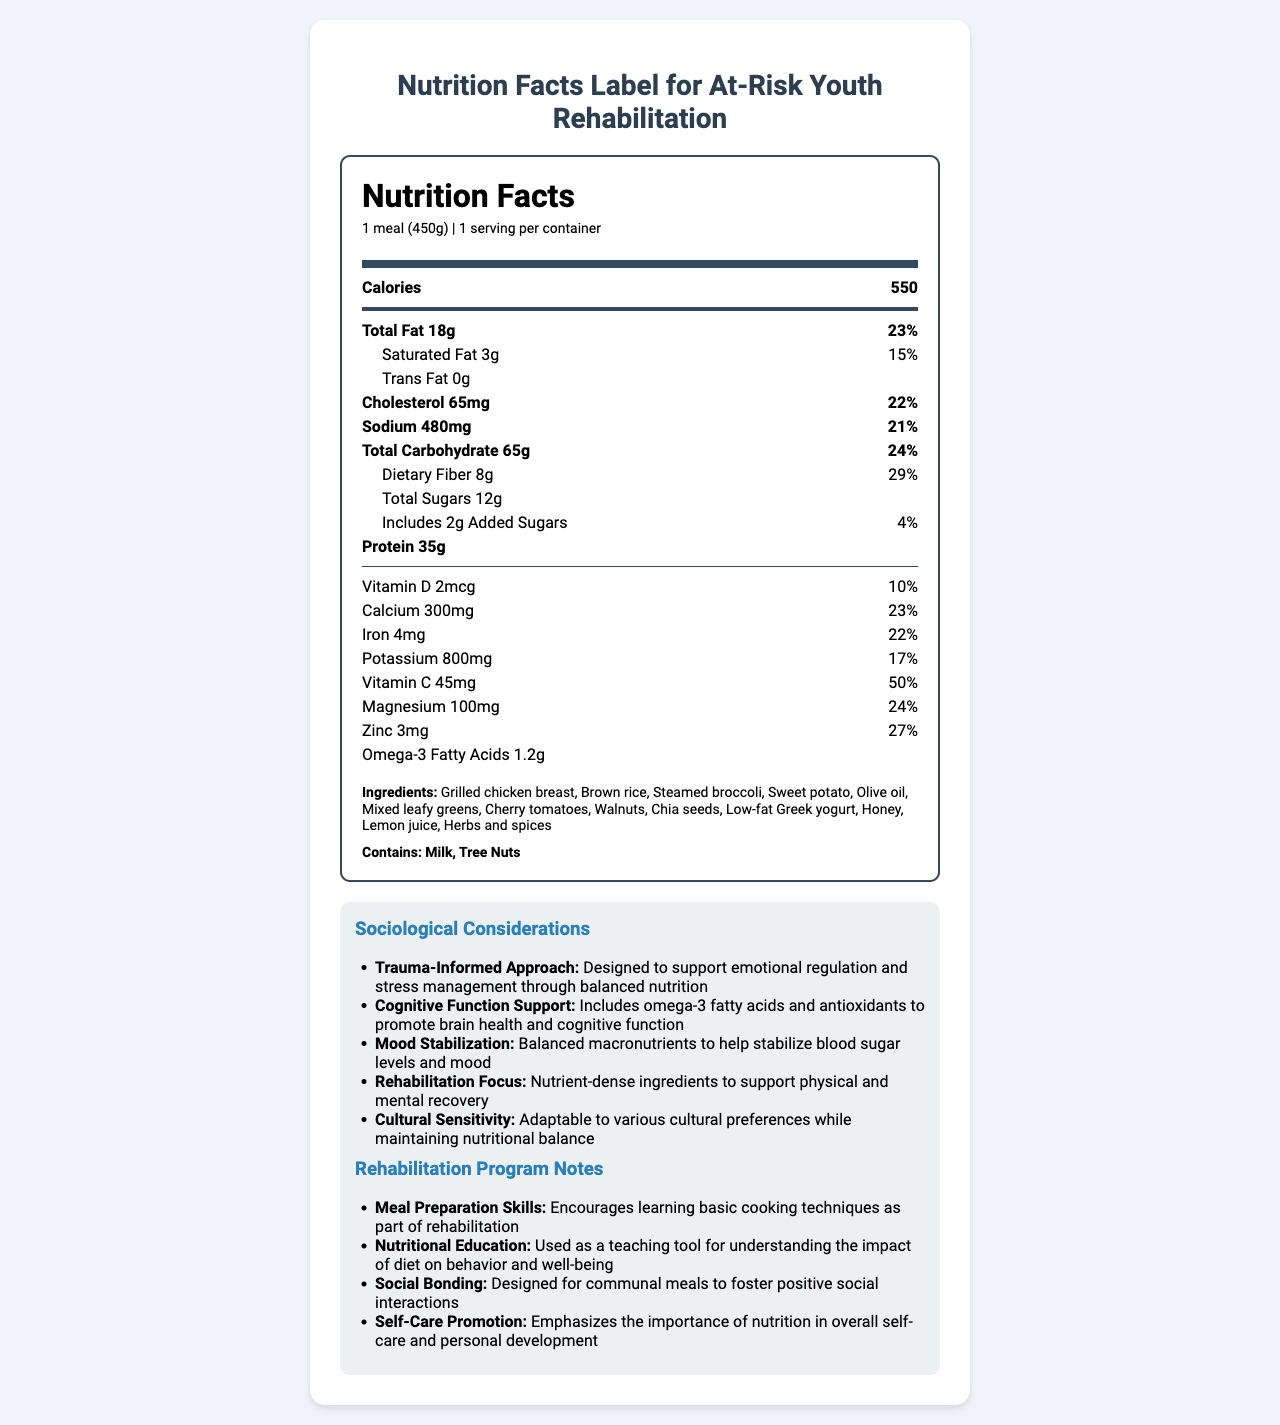What is the serving size of the Balanced Recovery Meal Plan? The document states that the serving size is "1 meal (450g)".
Answer: 1 meal (450g) How many grams of dietary fiber are in one serving of the meal plan? The nutrition facts label lists dietary fiber as 8g per serving.
Answer: 8g What percentage of the daily value is the total fat in one serving? The total fat amount given is 18g, which is 23% of the daily value.
Answer: 23% Does the meal contain any trans fat? The label specifies that trans fat is "0g".
Answer: No How many grams of protein does the meal contain? The nutrition facts label shows that the meal contains 35g of protein.
Answer: 35g Which of the following vitamins and minerals has the highest daily value percentage in the meal? A. Vitamin D B. Calcium C. Iron D. Vitamin C Vitamin C has the highest daily value percentage at 50%.
Answer: D. Vitamin C What is one of the main sociological considerations of this meal plan? A. High protein content B. Supports emotional regulation C. Low in calories D. Contains artificial ingredients One of the sociological considerations mentioned is that the meal plan is designed to support emotional regulation and stress management.
Answer: B. Supports emotional regulation What are the allergens listed in the meal plan? The allergens section in the document states "Contains: Milk, Tree Nuts".
Answer: Milk, Tree Nuts Is the meal plan adaptable to various cultural preferences? The sociological considerations include that the meal plan is culturally sensitive and adaptable to various cultural preferences.
Answer: Yes Summarize the main idea of the document. The document provides comprehensive information on the Balanced Recovery Meal Plan, including specific nutritional values, ingredients, and allergens. Additionally, it outlines sociological considerations and benefits for at-risk youth in rehabilitation programs, such as emotional regulation, cognitive function support, mood stabilization, and cultural adaptability.
Answer: The document describes the Balanced Recovery Meal Plan, detailing its nutritional content, ingredients, allergens, sociological considerations, and its role in a rehabilitation program for at-risk youth. What is the total amount of sugars in the meal, including added sugars? The total sugars amount is 12g, and the meal includes 2g of added sugars, making the total 14g.
Answer: 14g What cognitive benefits does the meal plan offer to at-risk youth? The document states that the meal includes omega-3 fatty acids and antioxidants to support cognitive function.
Answer: Promotes brain health and cognitive function What are the ingredients included in the meal plan that might be beneficial for rehabilitation and recovery? These ingredients are listed in the document under the "Ingredients" section and are nutrient-dense, supporting physical and mental recovery.
Answer: Grilled chicken breast, brown rice, steamed broccoli, sweet potato, olive oil, mixed leafy greens, cherry tomatoes, walnuts, chia seeds, low-fat Greek yogurt, honey, lemon juice, herbs, and spices Can the exact preparation method of the meal be determined from the document? The document does not provide detailed preparation instructions or methods, only the ingredients.
Answer: Not enough information What is the purpose of using this meal plan as a teaching tool? The rehabilitation program notes state that the meal plan is used to teach about the impact of diet on behavior and well-being.
Answer: Understanding the impact of diet on behavior and well-being 